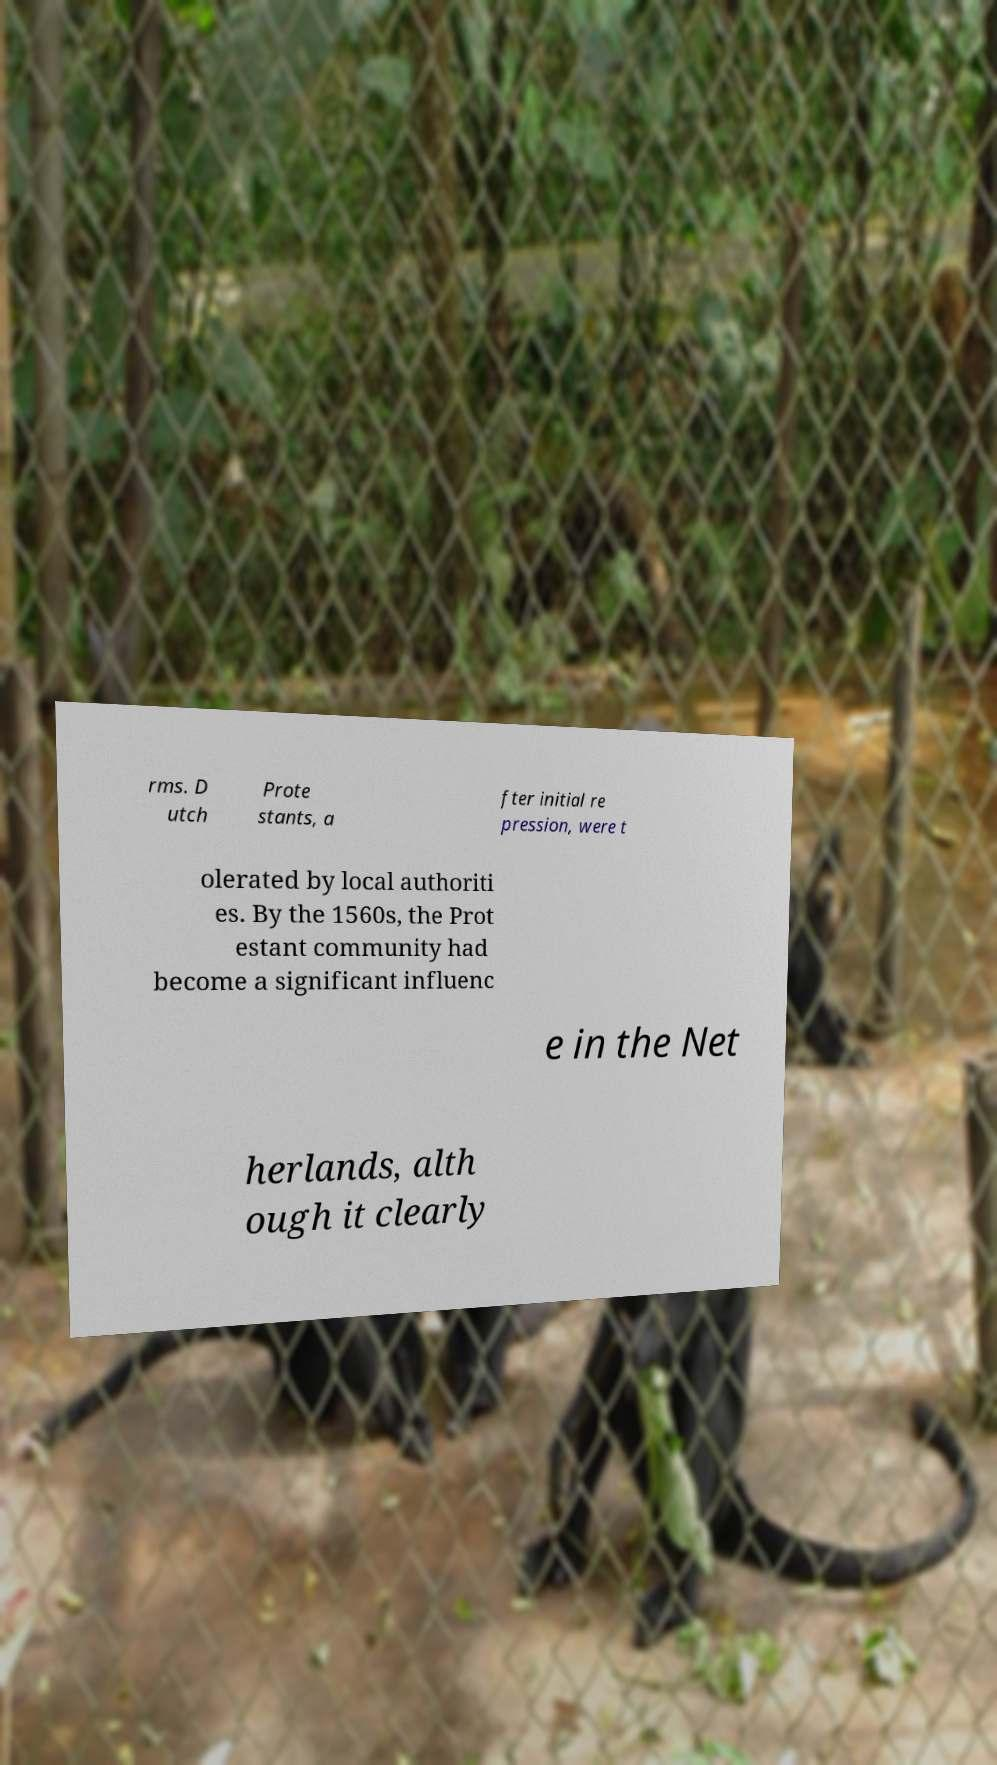What messages or text are displayed in this image? I need them in a readable, typed format. rms. D utch Prote stants, a fter initial re pression, were t olerated by local authoriti es. By the 1560s, the Prot estant community had become a significant influenc e in the Net herlands, alth ough it clearly 